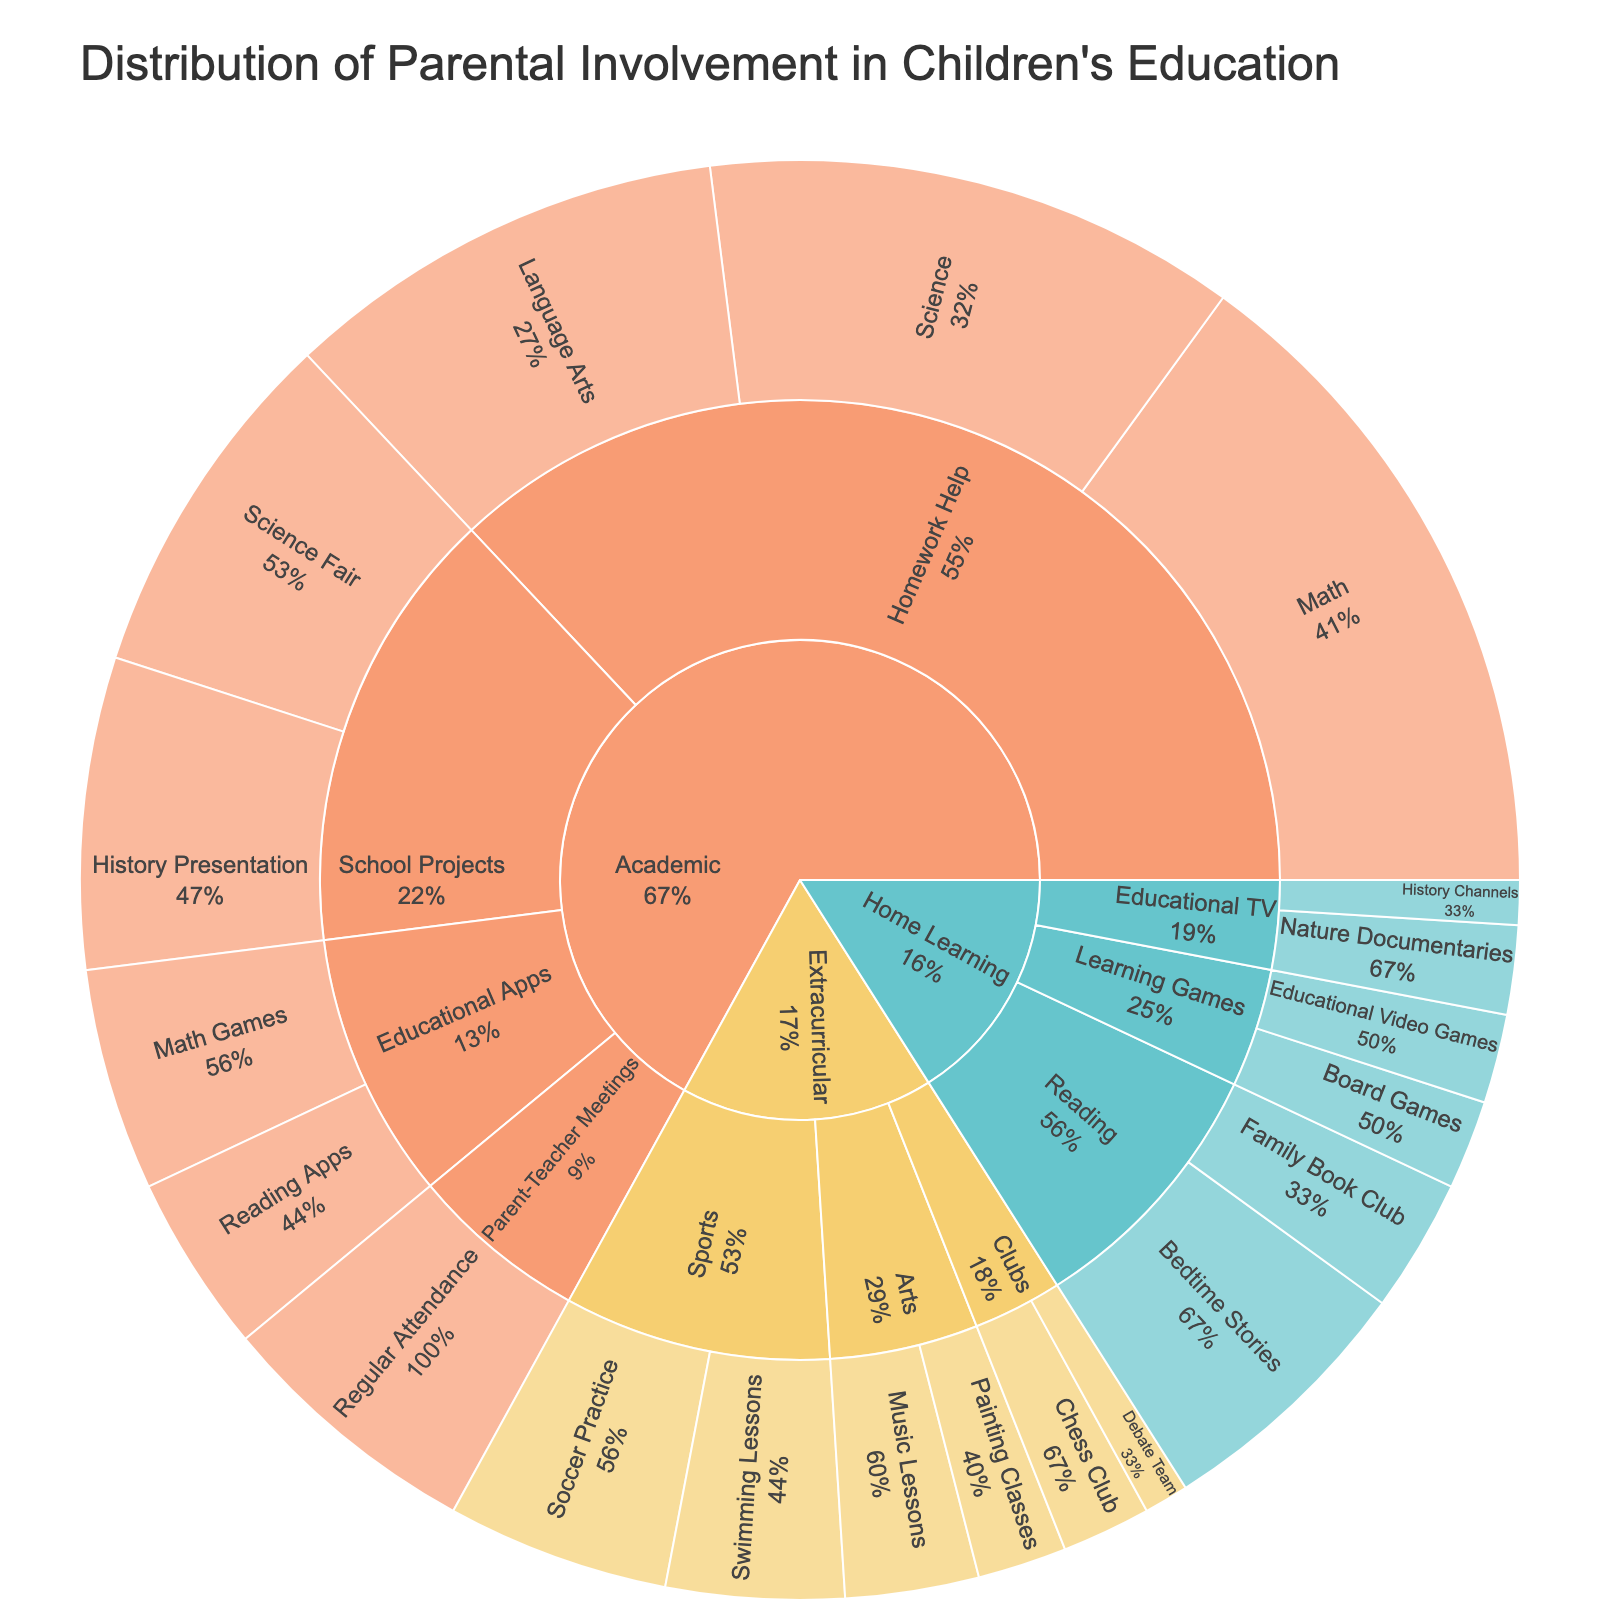What is the title of the Sunburst plot? The title is usually at the top of the plot and it provides a summary of what the data represents. In this case, the title would be descriptive of parental involvement.
Answer: Distribution of Parental Involvement in Children's Education Which subject area has the highest percentage of parental involvement in Homework Help? To find this, look at the section of the plot labeled Homework Help under the Academic subject and compare the segments for Math, Science, and Language Arts.
Answer: Math What is the combined percentage of parental involvement in Sports activities? Sum the percentages of Soccer Practice and Swimming Lessons under Sports in the Extracurricular section.
Answer: (5 + 4) = 9% Which engagement method within Academic has the smallest percentage? Compare the percentages of all the engagement methods under the Academic subject.
Answer: Educational Apps How do the percentages of parental involvement in reading activities at home compare? Look at the Bedtime Stories and Family Book Club segments under Reading in the Home Learning section and compare their percentages.
Answer: Bedtime Stories is higher What percentage of parental involvement is dedicated to Nature Documentaries in Home Learning? Identify the segment for Nature Documentaries under Educational TV in the Home Learning section and read the percentage.
Answer: 2% Which sports activity has a higher percentage of parental involvement, Soccer Practice or Swimming Lessons? Compare the percentages for Soccer Practice and Swimming Lessons under Sports in the Extracurricular section.
Answer: Soccer Practice In the Parenting-Teacher Meetings engagement method, what is the representative activity and its percentage? Look under Parent-Teacher Meetings in the Academic section to find the activity and its percentage.
Answer: Regular Attendance, 6% Do parents engage more in School Projects for Science Fair or History Presentation? Compare the percentages for Science Fair and History Presentation under School Projects in the Academic section.
Answer: Science Fair Among the activities under Learning Games in Home Learning, how is the parental involvement percentage distributed? Look at the percentages for Board Games and Educational Video Games under Learning Games in Home Learning and state their percentages.
Answer: Both are 2% each 